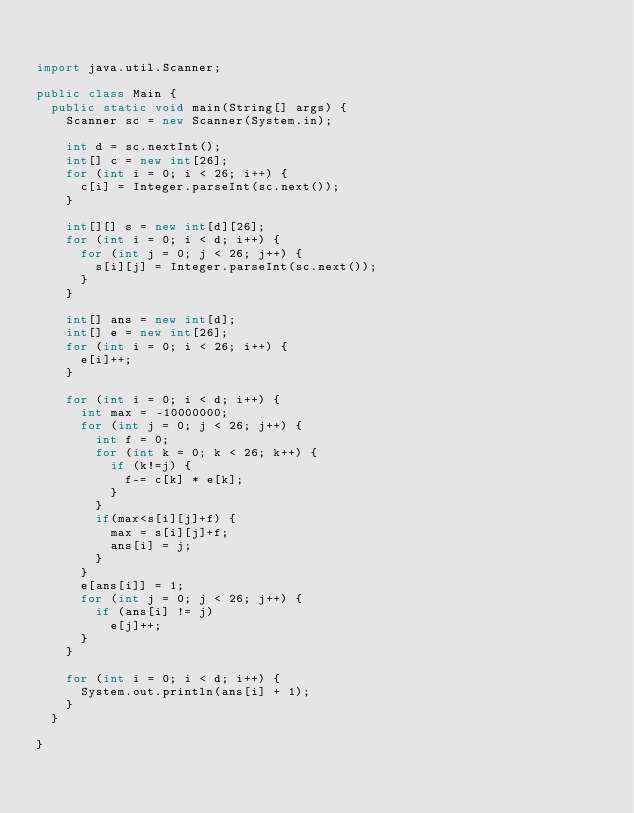<code> <loc_0><loc_0><loc_500><loc_500><_Java_>

import java.util.Scanner;

public class Main {
	public static void main(String[] args) {
		Scanner sc = new Scanner(System.in);

		int d = sc.nextInt();
		int[] c = new int[26];
		for (int i = 0; i < 26; i++) {
			c[i] = Integer.parseInt(sc.next());
		}

		int[][] s = new int[d][26];
		for (int i = 0; i < d; i++) {
			for (int j = 0; j < 26; j++) {
				s[i][j] = Integer.parseInt(sc.next());
			}
		}

		int[] ans = new int[d];
		int[] e = new int[26];
		for (int i = 0; i < 26; i++) {
			e[i]++;
		}

		for (int i = 0; i < d; i++) {
			int max = -10000000;
			for (int j = 0; j < 26; j++) {
				int f = 0;
				for (int k = 0; k < 26; k++) {
					if (k!=j) {
						f-= c[k] * e[k];
					}
				}
				if(max<s[i][j]+f) {
					max = s[i][j]+f;
					ans[i] = j;
				}
			}
			e[ans[i]] = 1;
			for (int j = 0; j < 26; j++) {
				if (ans[i] != j)
					e[j]++;
			}
		}

		for (int i = 0; i < d; i++) {
			System.out.println(ans[i] + 1);
		}
	}

}
</code> 